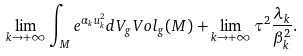<formula> <loc_0><loc_0><loc_500><loc_500>\lim _ { k \rightarrow + \infty } \int _ { M } e ^ { \alpha _ { k } u _ { k } ^ { 2 } } d V _ { g } V o l _ { g } ( M ) + \lim _ { k \rightarrow + \infty } \tau ^ { 2 } \frac { \lambda _ { k } } { \beta _ { k } ^ { 2 } } .</formula> 